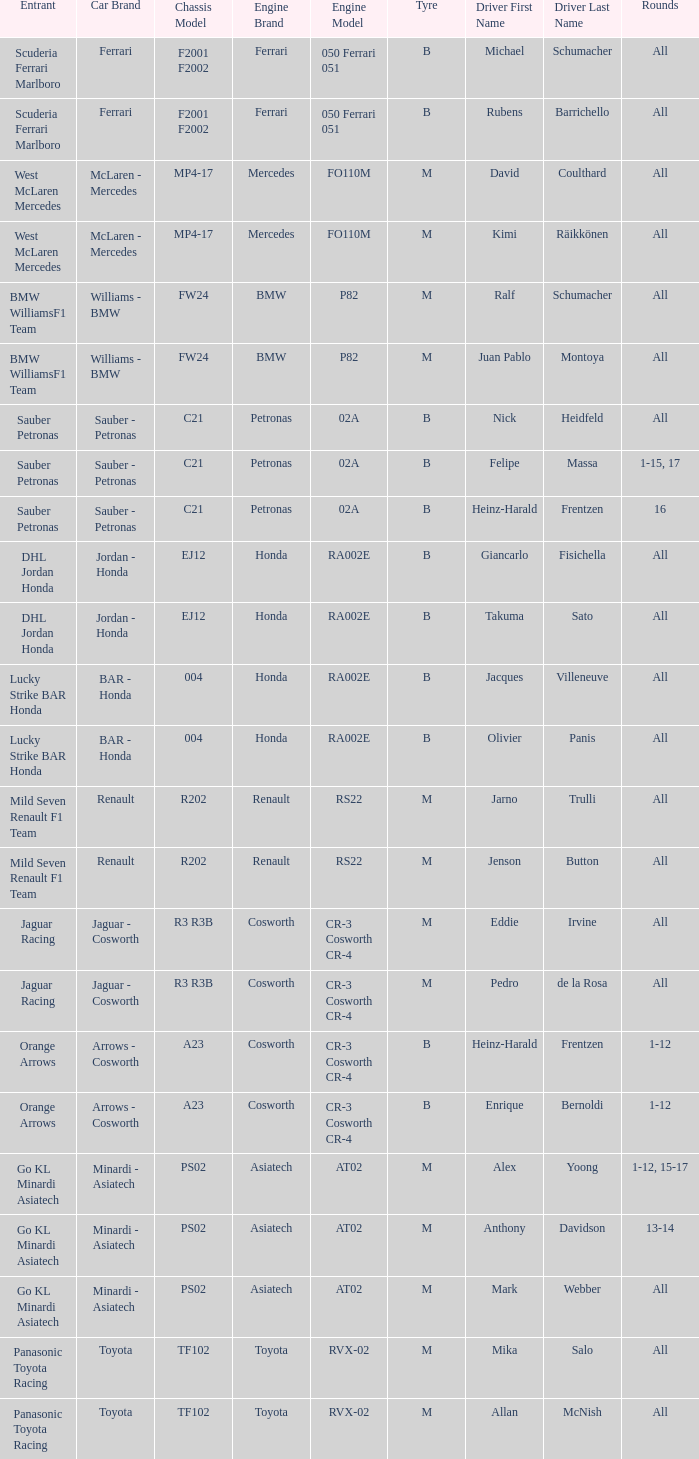Who is the entrant when the engine is bmw p82? BMW WilliamsF1 Team, BMW WilliamsF1 Team. Give me the full table as a dictionary. {'header': ['Entrant', 'Car Brand', 'Chassis Model', 'Engine Brand', 'Engine Model', 'Tyre', 'Driver First Name', 'Driver Last Name', 'Rounds'], 'rows': [['Scuderia Ferrari Marlboro', 'Ferrari', 'F2001 F2002', 'Ferrari', '050 Ferrari 051', 'B', 'Michael', 'Schumacher', 'All'], ['Scuderia Ferrari Marlboro', 'Ferrari', 'F2001 F2002', 'Ferrari', '050 Ferrari 051', 'B', 'Rubens', 'Barrichello', 'All'], ['West McLaren Mercedes', 'McLaren - Mercedes', 'MP4-17', 'Mercedes', 'FO110M', 'M', 'David', 'Coulthard', 'All'], ['West McLaren Mercedes', 'McLaren - Mercedes', 'MP4-17', 'Mercedes', 'FO110M', 'M', 'Kimi', 'Räikkönen', 'All'], ['BMW WilliamsF1 Team', 'Williams - BMW', 'FW24', 'BMW', 'P82', 'M', 'Ralf', 'Schumacher', 'All'], ['BMW WilliamsF1 Team', 'Williams - BMW', 'FW24', 'BMW', 'P82', 'M', 'Juan Pablo', 'Montoya', 'All'], ['Sauber Petronas', 'Sauber - Petronas', 'C21', 'Petronas', '02A', 'B', 'Nick', 'Heidfeld', 'All'], ['Sauber Petronas', 'Sauber - Petronas', 'C21', 'Petronas', '02A', 'B', 'Felipe', 'Massa', '1-15, 17'], ['Sauber Petronas', 'Sauber - Petronas', 'C21', 'Petronas', '02A', 'B', 'Heinz-Harald', 'Frentzen', '16'], ['DHL Jordan Honda', 'Jordan - Honda', 'EJ12', 'Honda', 'RA002E', 'B', 'Giancarlo', 'Fisichella', 'All'], ['DHL Jordan Honda', 'Jordan - Honda', 'EJ12', 'Honda', 'RA002E', 'B', 'Takuma', 'Sato', 'All'], ['Lucky Strike BAR Honda', 'BAR - Honda', '004', 'Honda', 'RA002E', 'B', 'Jacques', 'Villeneuve', 'All'], ['Lucky Strike BAR Honda', 'BAR - Honda', '004', 'Honda', 'RA002E', 'B', 'Olivier', 'Panis', 'All'], ['Mild Seven Renault F1 Team', 'Renault', 'R202', 'Renault', 'RS22', 'M', 'Jarno', 'Trulli', 'All'], ['Mild Seven Renault F1 Team', 'Renault', 'R202', 'Renault', 'RS22', 'M', 'Jenson', 'Button', 'All'], ['Jaguar Racing', 'Jaguar - Cosworth', 'R3 R3B', 'Cosworth', 'CR-3 Cosworth CR-4', 'M', 'Eddie', 'Irvine', 'All'], ['Jaguar Racing', 'Jaguar - Cosworth', 'R3 R3B', 'Cosworth', 'CR-3 Cosworth CR-4', 'M', 'Pedro', 'de la Rosa', 'All'], ['Orange Arrows', 'Arrows - Cosworth', 'A23', 'Cosworth', 'CR-3 Cosworth CR-4', 'B', 'Heinz-Harald', 'Frentzen', '1-12'], ['Orange Arrows', 'Arrows - Cosworth', 'A23', 'Cosworth', 'CR-3 Cosworth CR-4', 'B', 'Enrique', 'Bernoldi', '1-12'], ['Go KL Minardi Asiatech', 'Minardi - Asiatech', 'PS02', 'Asiatech', 'AT02', 'M', 'Alex', 'Yoong', '1-12, 15-17'], ['Go KL Minardi Asiatech', 'Minardi - Asiatech', 'PS02', 'Asiatech', 'AT02', 'M', 'Anthony', 'Davidson', '13-14'], ['Go KL Minardi Asiatech', 'Minardi - Asiatech', 'PS02', 'Asiatech', 'AT02', 'M', 'Mark', 'Webber', 'All'], ['Panasonic Toyota Racing', 'Toyota', 'TF102', 'Toyota', 'RVX-02', 'M', 'Mika', 'Salo', 'All'], ['Panasonic Toyota Racing', 'Toyota', 'TF102', 'Toyota', 'RVX-02', 'M', 'Allan', 'McNish', 'All']]} 